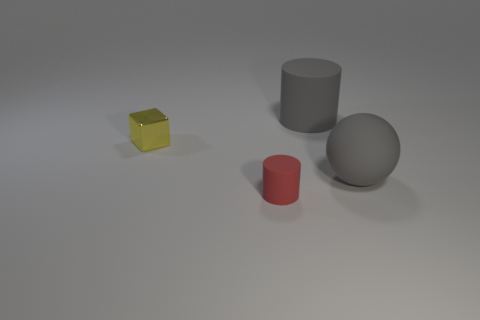Are there any gray rubber things?
Offer a terse response. Yes. There is a cylinder that is on the left side of the large cylinder; how many rubber cylinders are right of it?
Your answer should be compact. 1. What is the shape of the matte thing behind the sphere?
Your answer should be very brief. Cylinder. There is a small thing behind the large gray matte object on the right side of the rubber cylinder that is to the right of the tiny red cylinder; what is its material?
Make the answer very short. Metal. How many other objects are there of the same size as the yellow object?
Offer a terse response. 1. The tiny metal thing is what color?
Ensure brevity in your answer.  Yellow. What color is the large thing in front of the large thing behind the small block?
Make the answer very short. Gray. There is a big cylinder; does it have the same color as the big rubber thing in front of the yellow shiny block?
Offer a terse response. Yes. There is a big gray matte thing left of the large gray thing that is in front of the large rubber cylinder; how many matte things are on the left side of it?
Your answer should be very brief. 1. There is a yellow object; are there any small objects on the right side of it?
Make the answer very short. Yes. 